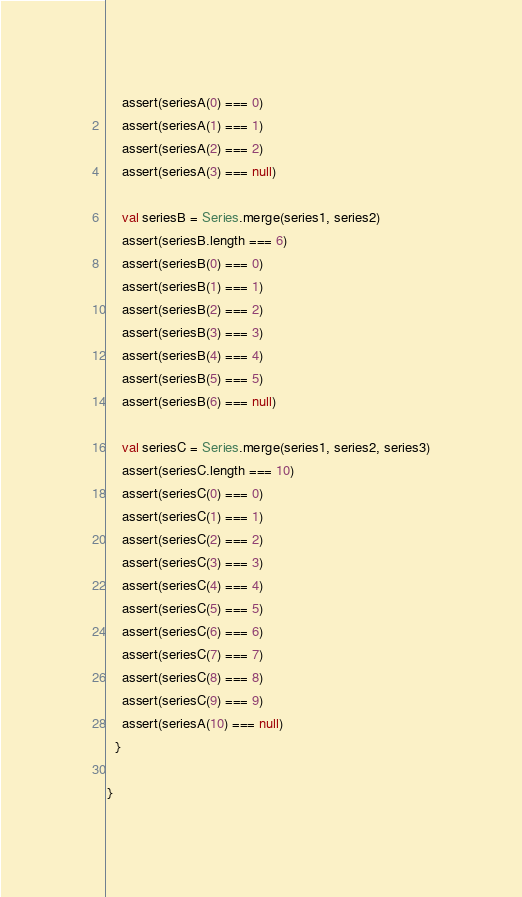Convert code to text. <code><loc_0><loc_0><loc_500><loc_500><_Scala_>    assert(seriesA(0) === 0)
    assert(seriesA(1) === 1)
    assert(seriesA(2) === 2)
    assert(seriesA(3) === null)

    val seriesB = Series.merge(series1, series2)
    assert(seriesB.length === 6)
    assert(seriesB(0) === 0)
    assert(seriesB(1) === 1)
    assert(seriesB(2) === 2)
    assert(seriesB(3) === 3)
    assert(seriesB(4) === 4)
    assert(seriesB(5) === 5)
    assert(seriesB(6) === null)

    val seriesC = Series.merge(series1, series2, series3)
    assert(seriesC.length === 10)
    assert(seriesC(0) === 0)
    assert(seriesC(1) === 1)
    assert(seriesC(2) === 2)
    assert(seriesC(3) === 3)
    assert(seriesC(4) === 4)
    assert(seriesC(5) === 5)
    assert(seriesC(6) === 6)
    assert(seriesC(7) === 7)
    assert(seriesC(8) === 8)
    assert(seriesC(9) === 9)
    assert(seriesA(10) === null)
  }

}
</code> 